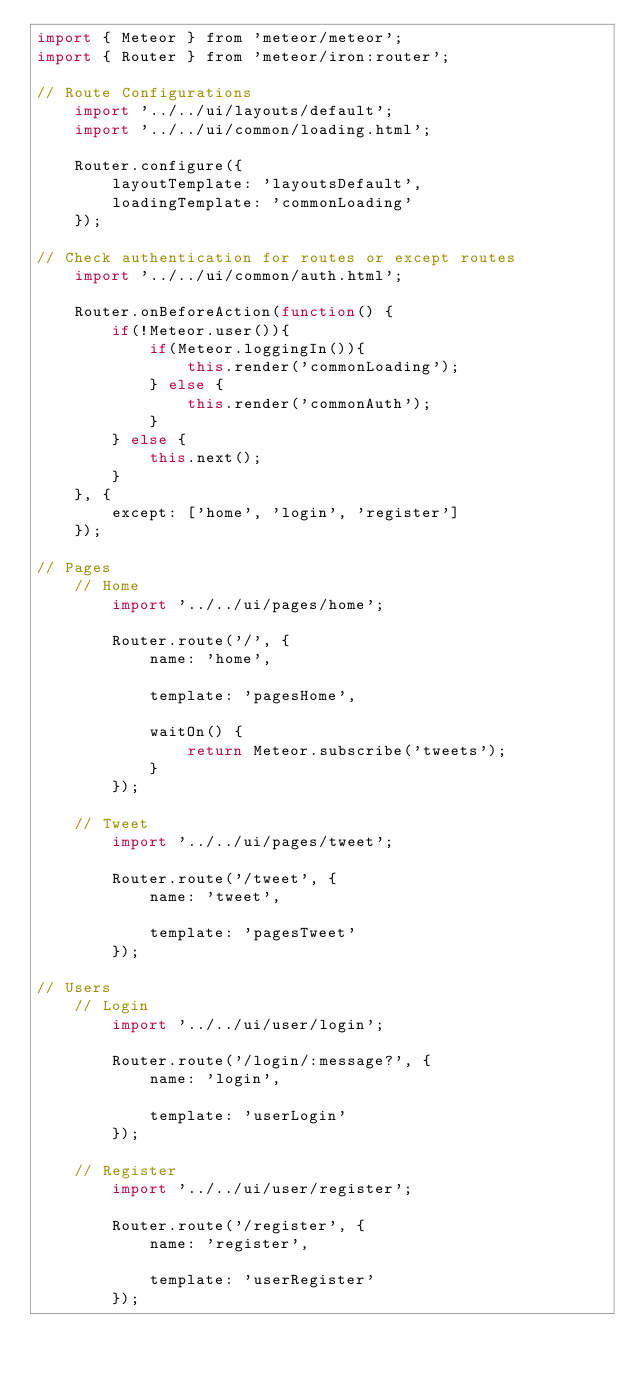Convert code to text. <code><loc_0><loc_0><loc_500><loc_500><_JavaScript_>import { Meteor } from 'meteor/meteor';
import { Router } from 'meteor/iron:router';

// Route Configurations
    import '../../ui/layouts/default';
    import '../../ui/common/loading.html';

    Router.configure({
        layoutTemplate: 'layoutsDefault',
        loadingTemplate: 'commonLoading'
    });

// Check authentication for routes or except routes
    import '../../ui/common/auth.html';

    Router.onBeforeAction(function() {
        if(!Meteor.user()){
            if(Meteor.loggingIn()){
                this.render('commonLoading');
            } else {
                this.render('commonAuth');
            }
        } else {
            this.next();
        }
    }, {
        except: ['home', 'login', 'register']
    });

// Pages
    // Home
        import '../../ui/pages/home';

        Router.route('/', {
            name: 'home',

            template: 'pagesHome',

            waitOn() {
                return Meteor.subscribe('tweets');
            }
        });

    // Tweet
        import '../../ui/pages/tweet';

        Router.route('/tweet', {
            name: 'tweet',

            template: 'pagesTweet'
        });

// Users
    // Login
        import '../../ui/user/login';

        Router.route('/login/:message?', {
            name: 'login',

            template: 'userLogin'
        });

    // Register
        import '../../ui/user/register';

        Router.route('/register', {
            name: 'register',

            template: 'userRegister'
        });</code> 